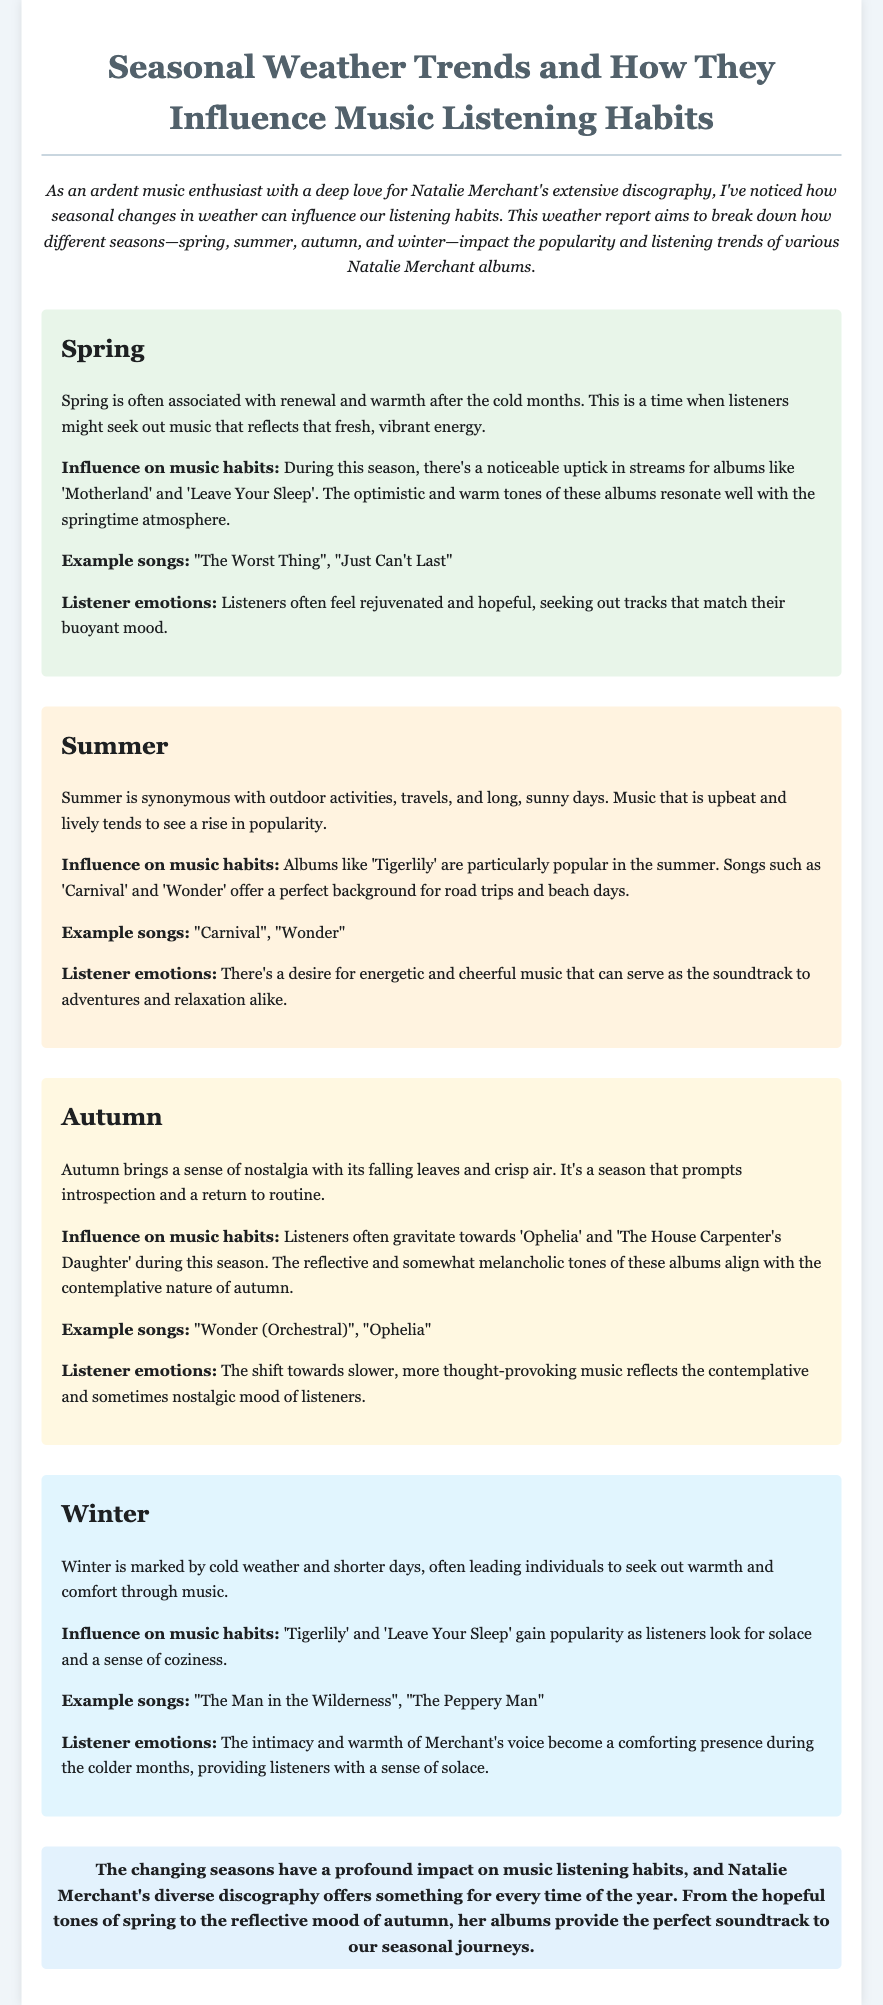What albums are popular in spring? The document states that 'Motherland' and 'Leave Your Sleep' see increased streams in spring.
Answer: 'Motherland' and 'Leave Your Sleep' Which Natalie Merchant album is highlighted for summer? The document mentions 'Tigerlily' as particularly popular during the summer.
Answer: 'Tigerlily' What song examples are provided for autumn? The document lists "Wonder (Orchestral)" and "Ophelia" as examples for autumn listening.
Answer: "Wonder (Orchestral)", "Ophelia" How does winter affect music listening habits? The document explains that listeners seek warmth and comfort through music during winter.
Answer: Warmth and comfort What influences music habits in spring? The document notes that the optimistic and warm tones of albums resonate well with springtime.
Answer: Optimistic and warm tones Which songs are popular in summer for road trips? The document states that "Carnival" and "Wonder" are perfect for road trips in summer.
Answer: "Carnival" and "Wonder" What listener emotions are associated with autumn? The document describes the emotions as contemplative and sometimes nostalgic during autumn.
Answer: Contemplative and nostalgic What is the concluding statement about seasonal music trends? The conclusion emphasizes that Natalie Merchant's discography provides perfect soundtracks for seasonal journeys.
Answer: Perfect soundtrack to our seasonal journeys Which albums gain popularity in winter? The document mentions 'Tigerlily' and 'Leave Your Sleep' gaining popularity in winter.
Answer: 'Tigerlily' and 'Leave Your Sleep' 